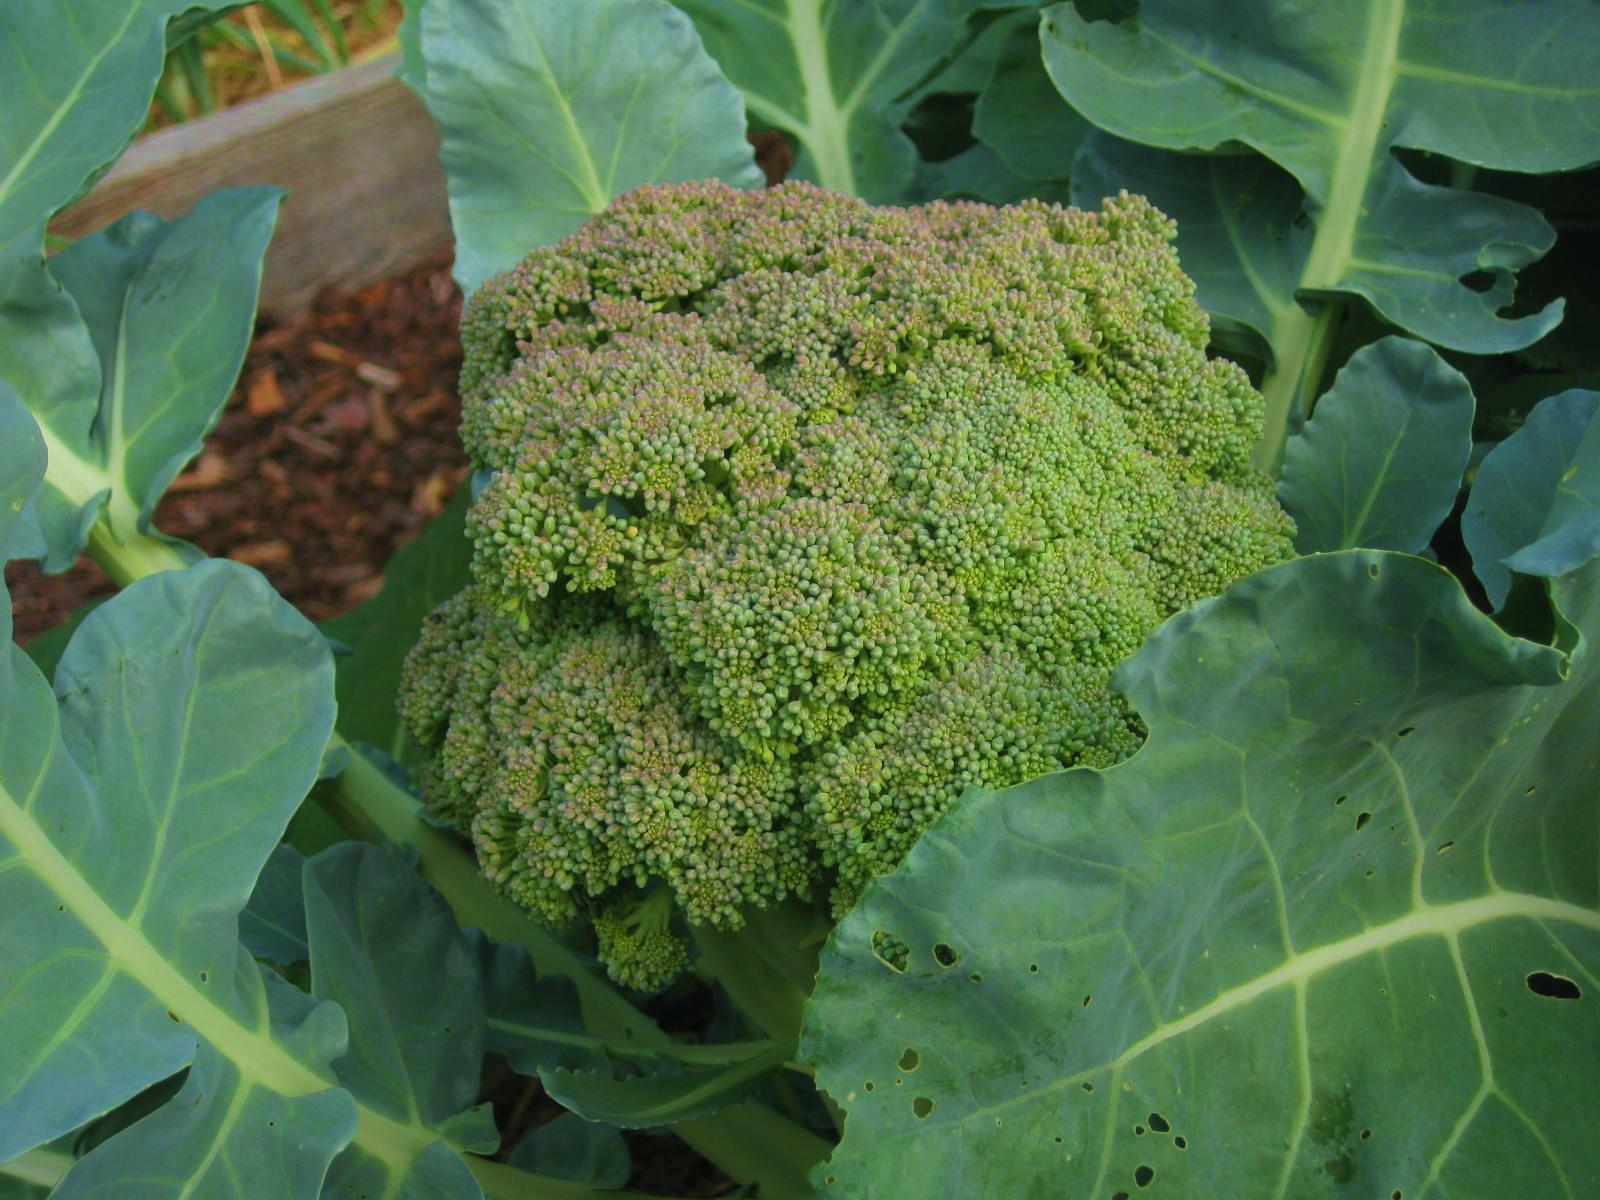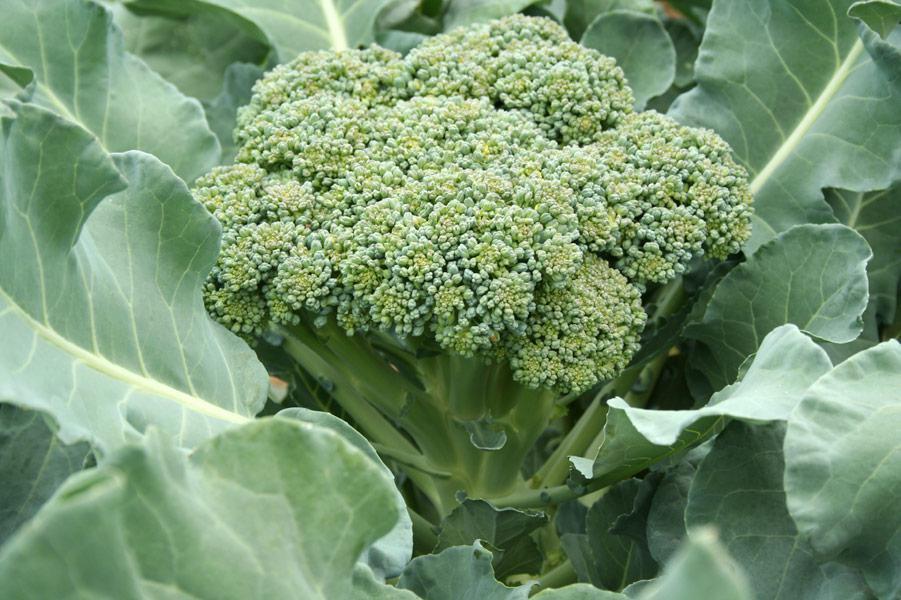The first image is the image on the left, the second image is the image on the right. For the images shown, is this caption "The plants are entirely green." true? Answer yes or no. Yes. 